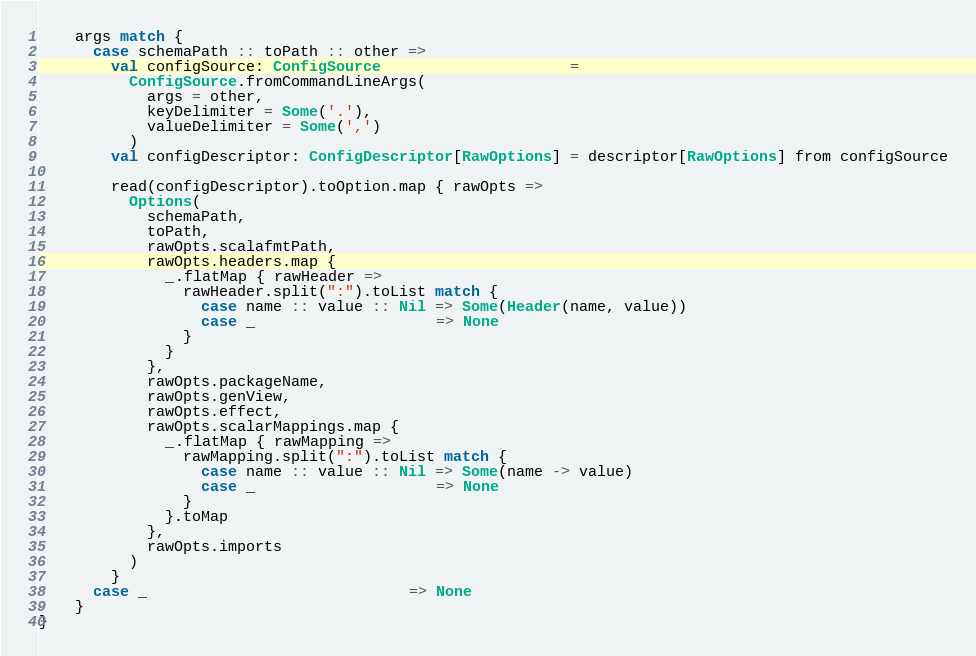Convert code to text. <code><loc_0><loc_0><loc_500><loc_500><_Scala_>    args match {
      case schemaPath :: toPath :: other =>
        val configSource: ConfigSource                     =
          ConfigSource.fromCommandLineArgs(
            args = other,
            keyDelimiter = Some('.'),
            valueDelimiter = Some(',')
          )
        val configDescriptor: ConfigDescriptor[RawOptions] = descriptor[RawOptions] from configSource

        read(configDescriptor).toOption.map { rawOpts =>
          Options(
            schemaPath,
            toPath,
            rawOpts.scalafmtPath,
            rawOpts.headers.map {
              _.flatMap { rawHeader =>
                rawHeader.split(":").toList match {
                  case name :: value :: Nil => Some(Header(name, value))
                  case _                    => None
                }
              }
            },
            rawOpts.packageName,
            rawOpts.genView,
            rawOpts.effect,
            rawOpts.scalarMappings.map {
              _.flatMap { rawMapping =>
                rawMapping.split(":").toList match {
                  case name :: value :: Nil => Some(name -> value)
                  case _                    => None
                }
              }.toMap
            },
            rawOpts.imports
          )
        }
      case _                             => None
    }
}
</code> 